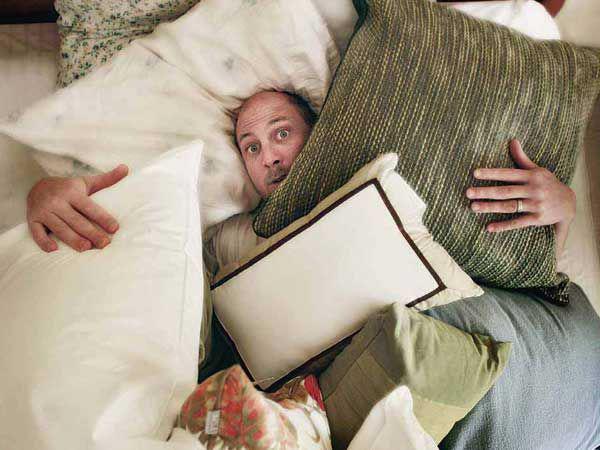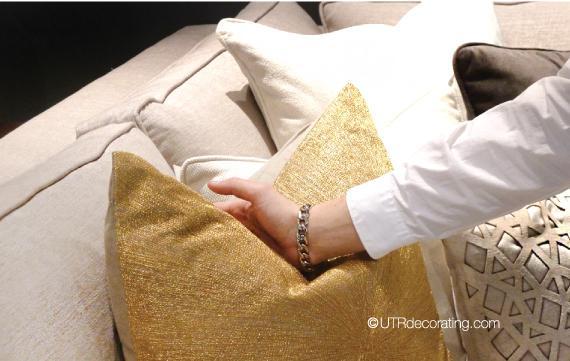The first image is the image on the left, the second image is the image on the right. Examine the images to the left and right. Is the description "In at least one image, a person is shown displaying fancy throw pillows." accurate? Answer yes or no. Yes. 